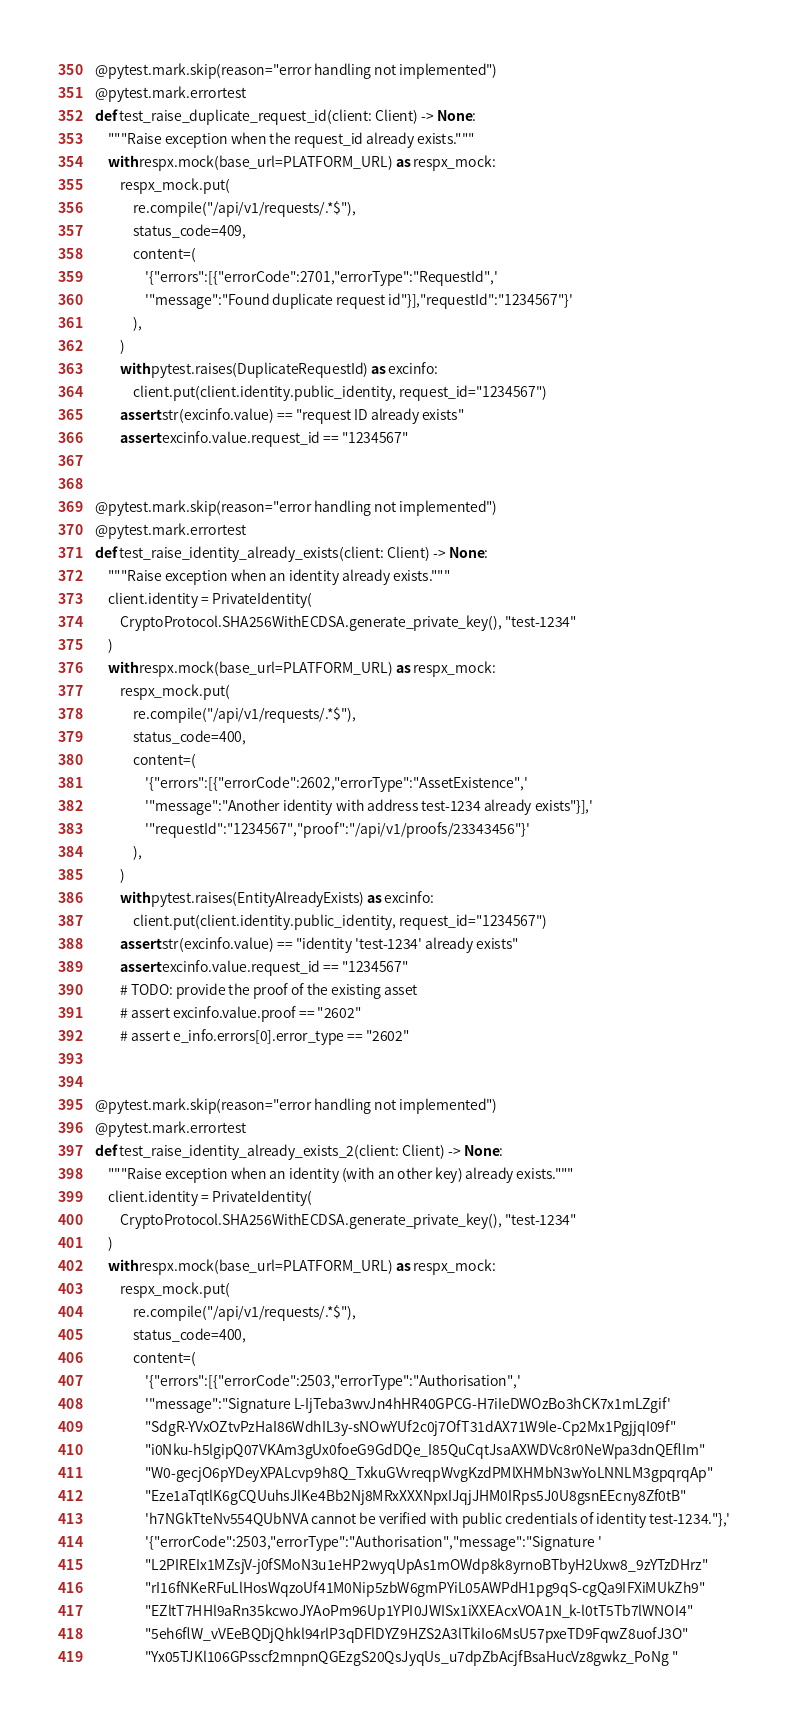Convert code to text. <code><loc_0><loc_0><loc_500><loc_500><_Python_>
@pytest.mark.skip(reason="error handling not implemented")
@pytest.mark.errortest
def test_raise_duplicate_request_id(client: Client) -> None:
    """Raise exception when the request_id already exists."""
    with respx.mock(base_url=PLATFORM_URL) as respx_mock:
        respx_mock.put(
            re.compile("/api/v1/requests/.*$"),
            status_code=409,
            content=(
                '{"errors":[{"errorCode":2701,"errorType":"RequestId",'
                '"message":"Found duplicate request id"}],"requestId":"1234567"}'
            ),
        )
        with pytest.raises(DuplicateRequestId) as excinfo:
            client.put(client.identity.public_identity, request_id="1234567")
        assert str(excinfo.value) == "request ID already exists"
        assert excinfo.value.request_id == "1234567"


@pytest.mark.skip(reason="error handling not implemented")
@pytest.mark.errortest
def test_raise_identity_already_exists(client: Client) -> None:
    """Raise exception when an identity already exists."""
    client.identity = PrivateIdentity(
        CryptoProtocol.SHA256WithECDSA.generate_private_key(), "test-1234"
    )
    with respx.mock(base_url=PLATFORM_URL) as respx_mock:
        respx_mock.put(
            re.compile("/api/v1/requests/.*$"),
            status_code=400,
            content=(
                '{"errors":[{"errorCode":2602,"errorType":"AssetExistence",'
                '"message":"Another identity with address test-1234 already exists"}],'
                '"requestId":"1234567","proof":"/api/v1/proofs/23343456"}'
            ),
        )
        with pytest.raises(EntityAlreadyExists) as excinfo:
            client.put(client.identity.public_identity, request_id="1234567")
        assert str(excinfo.value) == "identity 'test-1234' already exists"
        assert excinfo.value.request_id == "1234567"
        # TODO: provide the proof of the existing asset
        # assert excinfo.value.proof == "2602"
        # assert e_info.errors[0].error_type == "2602"


@pytest.mark.skip(reason="error handling not implemented")
@pytest.mark.errortest
def test_raise_identity_already_exists_2(client: Client) -> None:
    """Raise exception when an identity (with an other key) already exists."""
    client.identity = PrivateIdentity(
        CryptoProtocol.SHA256WithECDSA.generate_private_key(), "test-1234"
    )
    with respx.mock(base_url=PLATFORM_URL) as respx_mock:
        respx_mock.put(
            re.compile("/api/v1/requests/.*$"),
            status_code=400,
            content=(
                '{"errors":[{"errorCode":2503,"errorType":"Authorisation",'
                '"message":"Signature L-IjTeba3wvJn4hHR40GPCG-H7iIeDWOzBo3hCK7x1mLZgif'
                "SdgR-YVxOZtvPzHaI86WdhIL3y-sNOwYUf2c0j7OfT31dAX71W9le-Cp2Mx1PgjjqI09f"
                "i0Nku-h5lgipQ07VKAm3gUx0foeG9GdDQe_I85QuCqtJsaAXWDVc8r0NeWpa3dnQEflIm"
                "W0-gecjO6pYDeyXPALcvp9h8Q_TxkuGVvreqpWvgKzdPMlXHMbN3wYoLNNLM3gpqrqAp"
                "Eze1aTqtlK6gCQUuhsJlKe4Bb2Nj8MRxXXXNpxIJqjJHM0IRps5J0U8gsnEEcny8Zf0tB"
                'h7NGkTteNv554QUbNVA cannot be verified with public credentials of identity test-1234."},'
                '{"errorCode":2503,"errorType":"Authorisation","message":"Signature '
                "L2PIREIx1MZsjV-j0fSMoN3u1eHP2wyqUpAs1mOWdp8k8yrnoBTbyH2Uxw8_9zYTzDHrz"
                "rI16fNKeRFuLlHosWqzoUf41M0Nip5zbW6gmPYiL05AWPdH1pg9qS-cgQa9IFXiMUkZh9"
                "EZltT7HHl9aRn35kcwoJYAoPm96Up1YPI0JWISx1iXXEAcxVOA1N_k-l0tT5Tb7lWNOI4"
                "5eh6flW_vVEeBQDjQhkl94rlP3qDFlDYZ9HZS2A3lTkiIo6MsU57pxeTD9FqwZ8uofJ3O"
                "Yx05TJKl106GPsscf2mnpnQGEzgS20QsJyqUs_u7dpZbAcjfBsaHucVz8gwkz_PoNg "</code> 